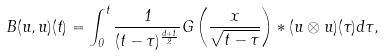<formula> <loc_0><loc_0><loc_500><loc_500>B ( u , u ) ( t ) = \int _ { 0 } ^ { t } \frac { 1 } { ( t - \tau ) ^ { \frac { d + 1 } { 2 } } } G \left ( \frac { x } { \sqrt { t - \tau } } \right ) * ( u \otimes u ) ( \tau ) d \tau ,</formula> 